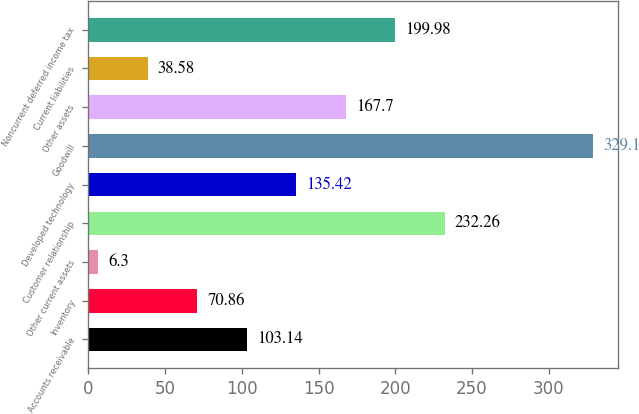<chart> <loc_0><loc_0><loc_500><loc_500><bar_chart><fcel>Accounts receivable<fcel>Inventory<fcel>Other current assets<fcel>Customer relationship<fcel>Developed technology<fcel>Goodwill<fcel>Other assets<fcel>Current liabilities<fcel>Noncurrent deferred income tax<nl><fcel>103.14<fcel>70.86<fcel>6.3<fcel>232.26<fcel>135.42<fcel>329.1<fcel>167.7<fcel>38.58<fcel>199.98<nl></chart> 